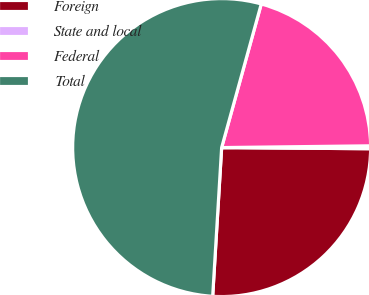Convert chart to OTSL. <chart><loc_0><loc_0><loc_500><loc_500><pie_chart><fcel>Foreign<fcel>State and local<fcel>Federal<fcel>Total<nl><fcel>25.84%<fcel>0.31%<fcel>20.53%<fcel>53.33%<nl></chart> 